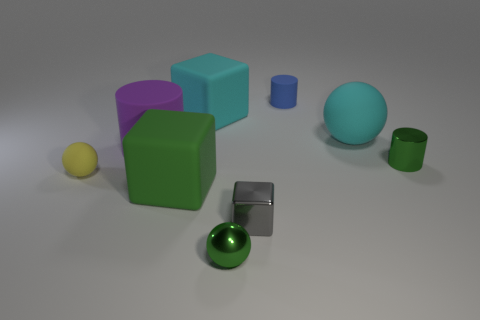Subtract all yellow rubber balls. How many balls are left? 2 Subtract all cyan balls. How many balls are left? 2 Subtract 0 blue spheres. How many objects are left? 9 Subtract all cubes. How many objects are left? 6 Subtract 1 spheres. How many spheres are left? 2 Subtract all brown spheres. Subtract all brown cubes. How many spheres are left? 3 Subtract all purple cylinders. How many cyan spheres are left? 1 Subtract all large blue metallic cubes. Subtract all tiny green objects. How many objects are left? 7 Add 3 large cylinders. How many large cylinders are left? 4 Add 7 big purple matte objects. How many big purple matte objects exist? 8 